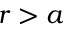<formula> <loc_0><loc_0><loc_500><loc_500>r > a</formula> 